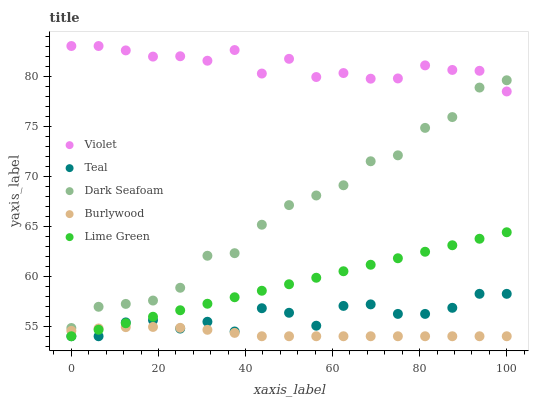Does Burlywood have the minimum area under the curve?
Answer yes or no. Yes. Does Violet have the maximum area under the curve?
Answer yes or no. Yes. Does Dark Seafoam have the minimum area under the curve?
Answer yes or no. No. Does Dark Seafoam have the maximum area under the curve?
Answer yes or no. No. Is Lime Green the smoothest?
Answer yes or no. Yes. Is Teal the roughest?
Answer yes or no. Yes. Is Dark Seafoam the smoothest?
Answer yes or no. No. Is Dark Seafoam the roughest?
Answer yes or no. No. Does Burlywood have the lowest value?
Answer yes or no. Yes. Does Dark Seafoam have the lowest value?
Answer yes or no. No. Does Violet have the highest value?
Answer yes or no. Yes. Does Dark Seafoam have the highest value?
Answer yes or no. No. Is Teal less than Dark Seafoam?
Answer yes or no. Yes. Is Dark Seafoam greater than Teal?
Answer yes or no. Yes. Does Teal intersect Lime Green?
Answer yes or no. Yes. Is Teal less than Lime Green?
Answer yes or no. No. Is Teal greater than Lime Green?
Answer yes or no. No. Does Teal intersect Dark Seafoam?
Answer yes or no. No. 